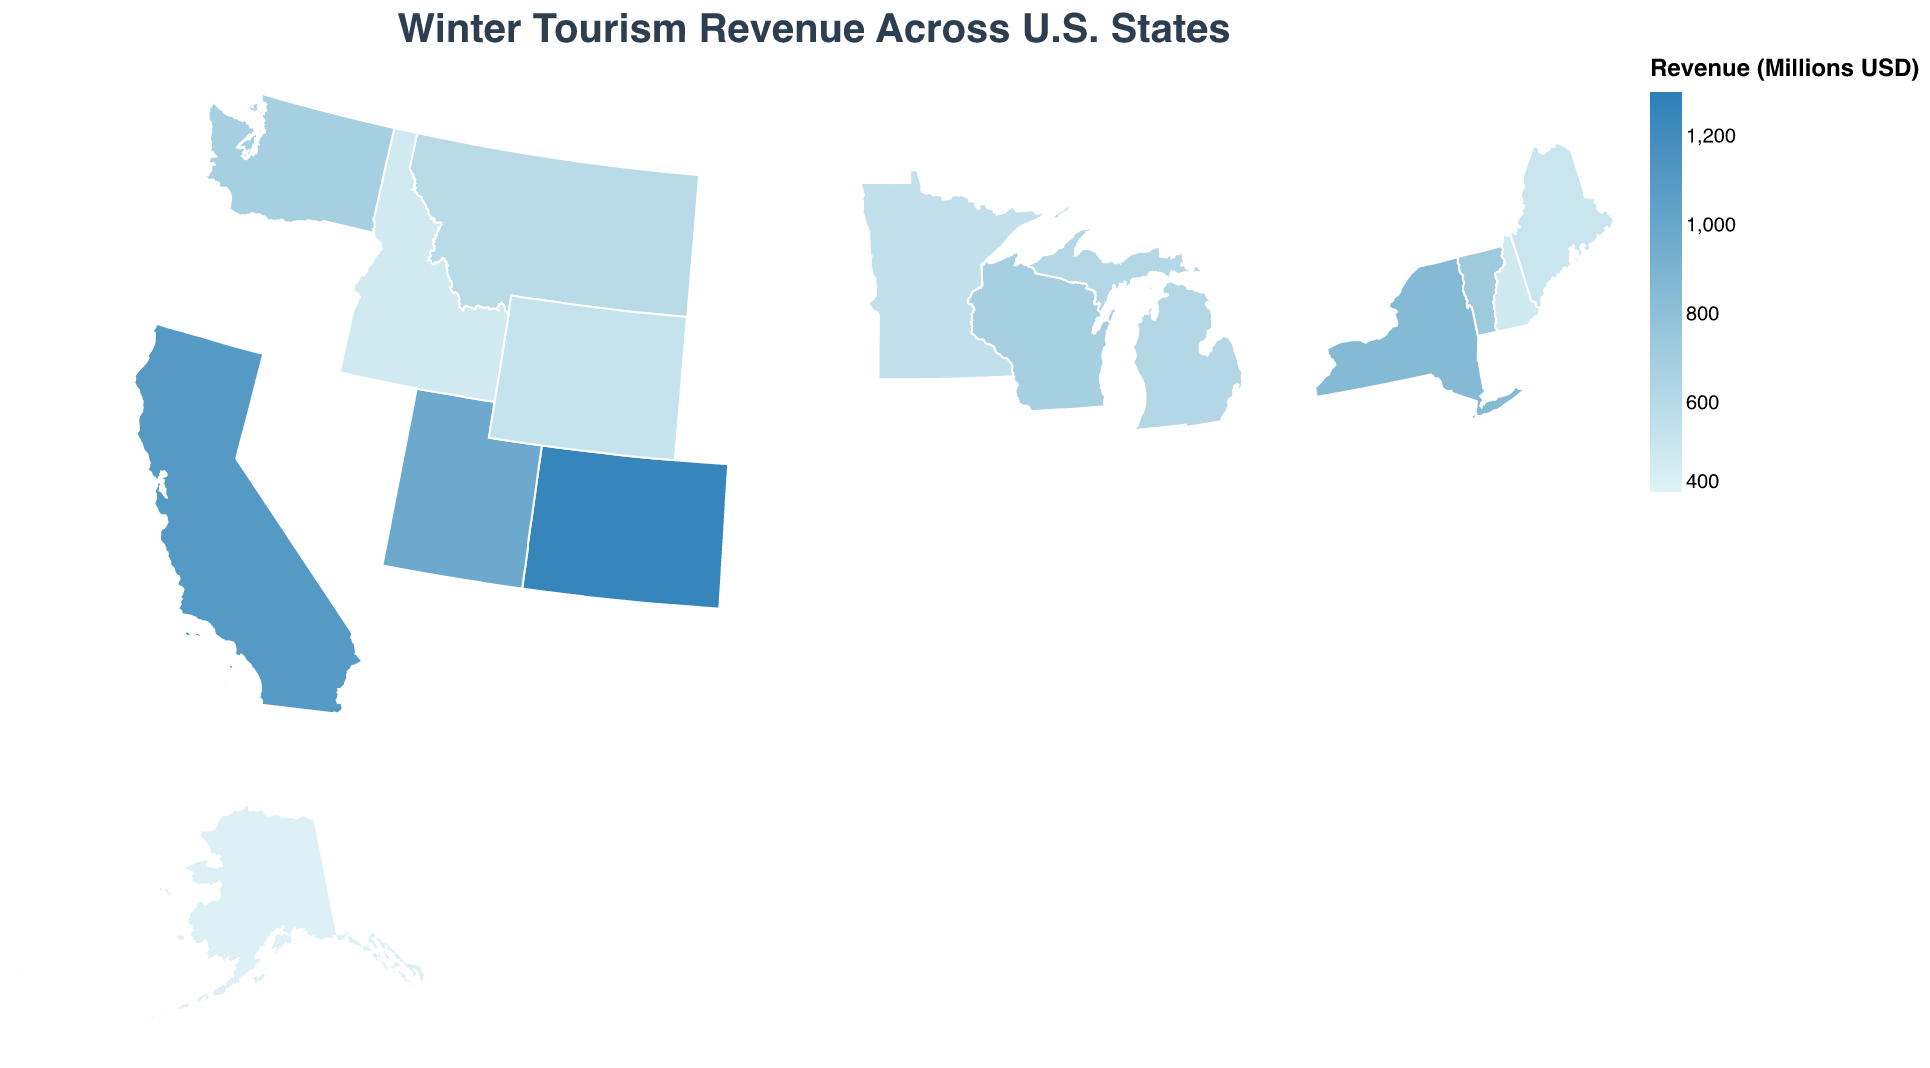Which state has the highest winter tourism revenue? The figure uses a color scale to represent the winter tourism revenue, where darker blue shades indicate higher revenues. By observing the darkest blue shade, we can see that Colorado has the highest revenue.
Answer: Colorado What is the winter tourism revenue of Wisconsin? By hovering over or checking the tooltip associated with Wisconsin on the map, the winter tourism revenue is listed as 680 million USD.
Answer: 680 million USD Which states have winter tourism revenues higher than Wisconsin but lower than California? Looking at the color shades and tooltips, the states fitting this criterion are New York and Utah. New York has 850 million USD and Utah has 980 million USD, both are higher than Wisconsin's 680 million USD but lower than California's 1100 million USD.
Answer: New York, Utah What is the combined winter tourism revenue for Vermont and Michigan? By checking the values of Vermont (720 million USD) and Michigan (620 million USD), the combined revenue is calculated by summing the two values: 720 + 620 = 1340 million USD.
Answer: 1340 million USD Compare the winter tourism revenue between Minnesota and Maine. Which state has a higher revenue? By referring to the tooltips of both Minnesota (550 million USD) and Maine (510 million USD), we can see that Minnesota has a higher revenue.
Answer: Minnesota What's the difference in winter tourism revenue between Colorado and Alaska? The tooltip for Colorado reads 1250 million USD and for Alaska 420 million USD. The difference is calculated as 1250 - 420 = 830 million USD.
Answer: 830 million USD Which state has the lowest winter tourism revenue? The figure uses a lighter shade of blue for lower revenues. Hovering over or checking the tooltip for the lightest shade, we can see that Idaho has the lowest revenue at 470 million USD.
Answer: Idaho How many states have a winter tourism revenue of 500 million USD or more? By counting the states with tooltips indicating 500 million USD or more (Colorado, Utah, Vermont, Wisconsin, New York, California, Montana, Michigan, Maine, Wyoming, Minnesota, Washington), there are 12 states.
Answer: 12 What is the average winter tourism revenue across all the states shown? Add up all the revenues: 1250 + 980 + 720 + 680 + 850 + 1100 + 590 + 620 + 510 + 480 + 530 + 470 + 550 + 420 + 680 = 10430 million USD. Divide by the number of states (15), which results in 10430 / 15 ≈ 695.33 million USD.
Answer: Approximately 695.33 million USD 